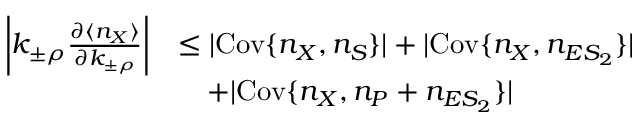Convert formula to latex. <formula><loc_0><loc_0><loc_500><loc_500>\begin{array} { r l } { \left | k _ { \pm \rho } \frac { \partial \langle n _ { X } \rangle } { \partial k _ { \pm \rho } } \right | } & { \leq | C o v \{ n _ { X } , n _ { S } \} | + | C o v \{ n _ { X } , n _ { E S _ { 2 } } \} | } \\ & { + | C o v \{ n _ { X } , n _ { P } + n _ { E S _ { 2 } } \} | } \end{array}</formula> 